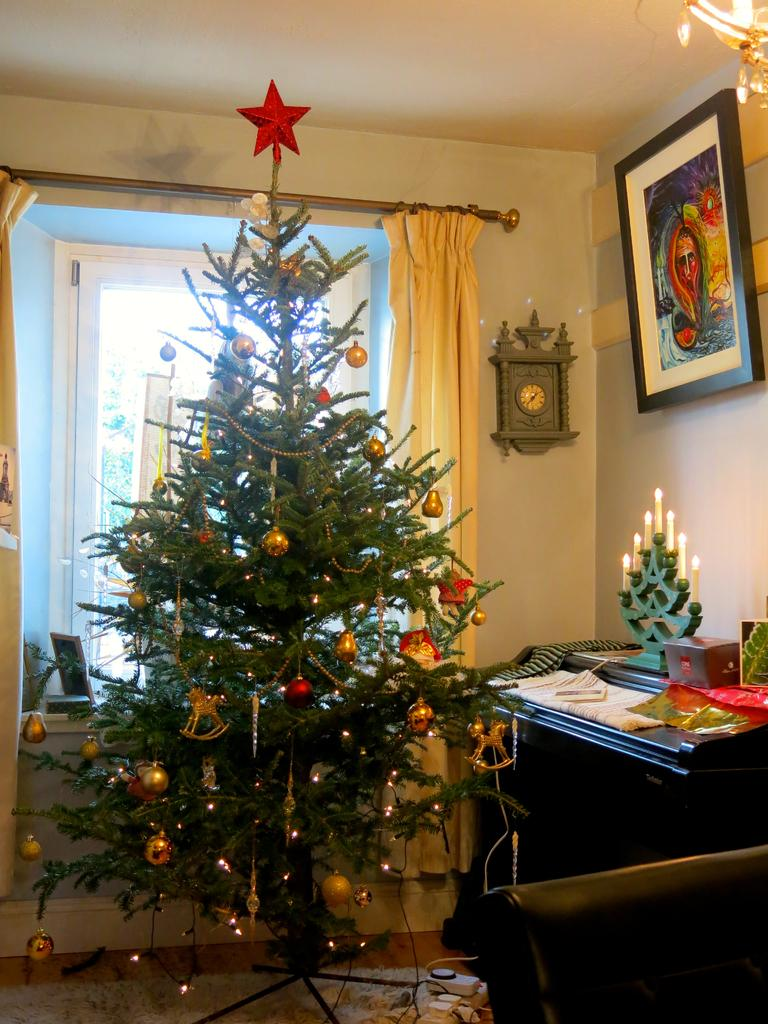What type of tree is in the image? There is a Christmas tree in the image. What object is used for measuring time in the image? There is a clock in the image. What is hanging on the wall in the image? There is a frame on the wall in the image. How many boys are playing with a bucket in the image? There are no boys or buckets present in the image. What type of organization is depicted in the frame on the wall? There is no organization depicted in the frame on the wall; it is not mentioned in the provided facts. 